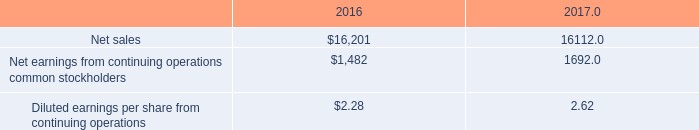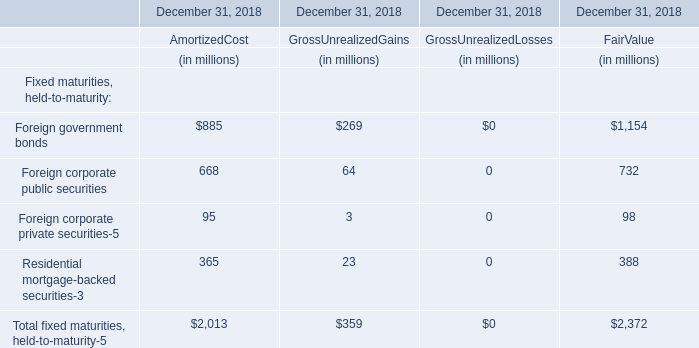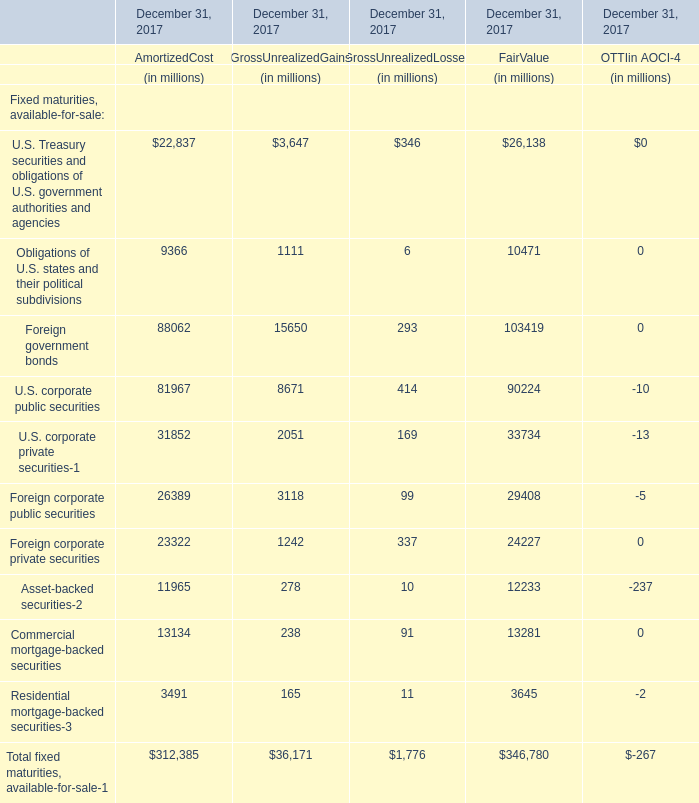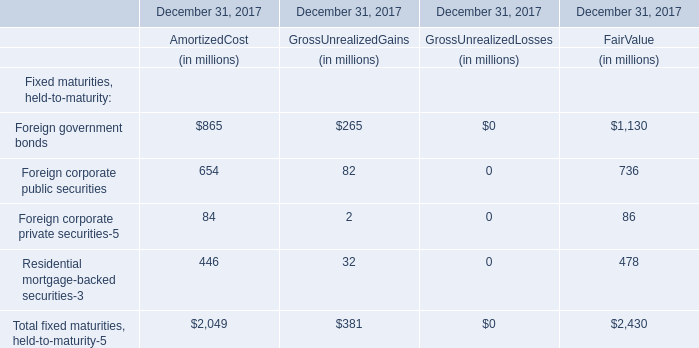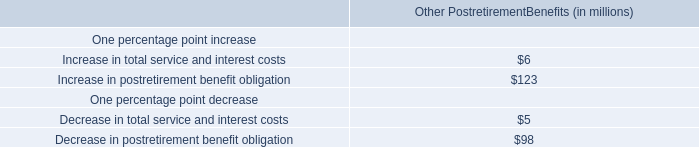In which section the sum of fair value has the highest value? 
Answer: Amortized Cost(860). 